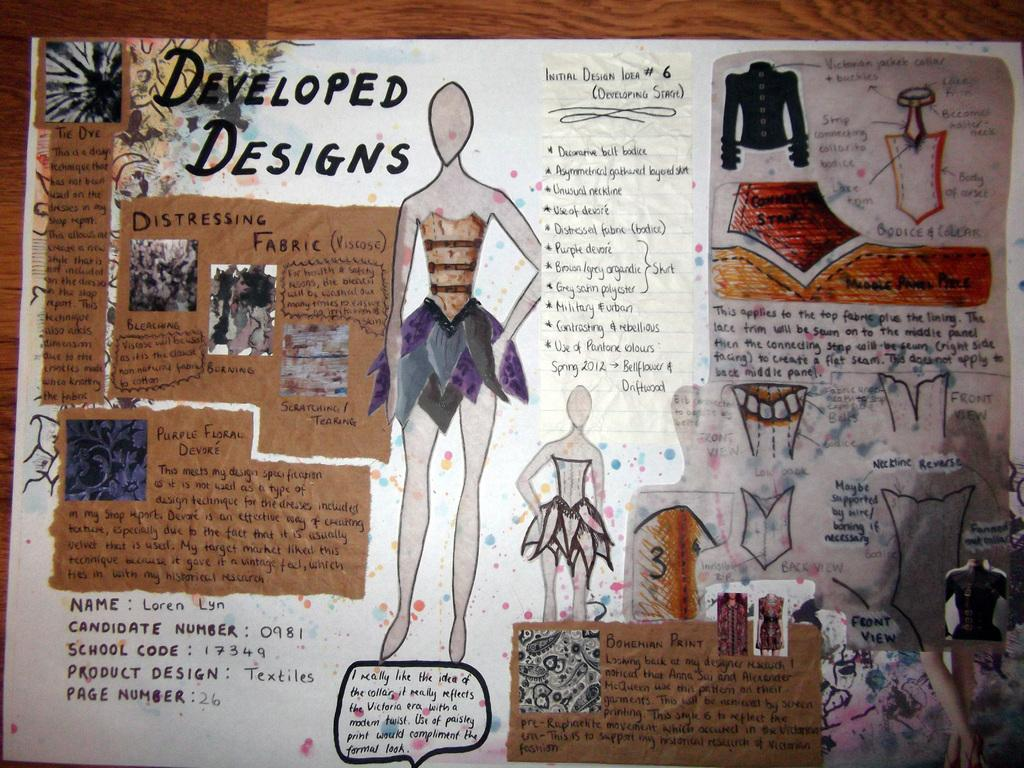What is featured on the poster in the image? There is a poster in the image that has both writing and drawings on it. What is the poster placed on? The poster is on a wooden surface. What type of building can be seen in the background of the image? There is no building visible in the image; it only features a poster on a wooden surface. Can you see any popcorn on the poster? There is no popcorn depicted on the poster in the image. 